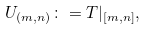<formula> <loc_0><loc_0><loc_500><loc_500>U _ { ( m , n ) } \colon = T | _ { [ m , n ] } ,</formula> 